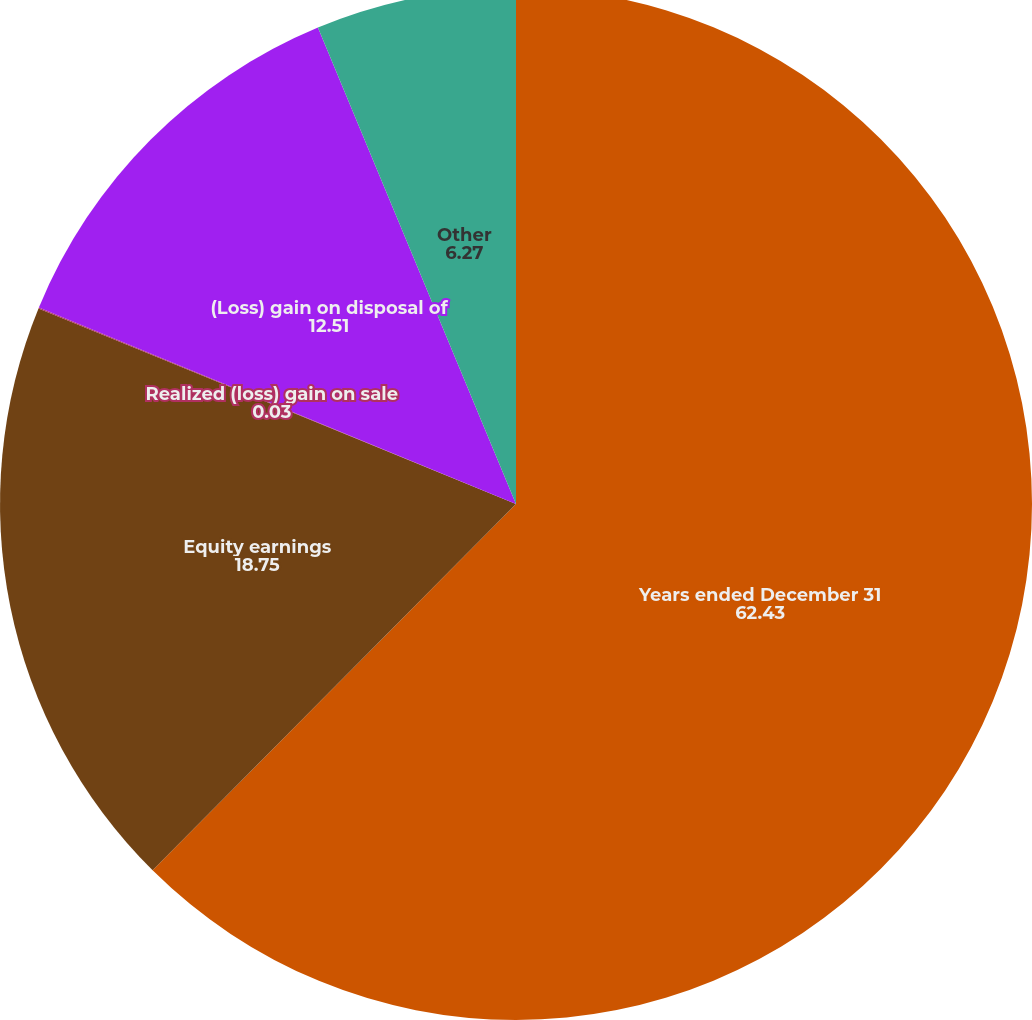Convert chart. <chart><loc_0><loc_0><loc_500><loc_500><pie_chart><fcel>Years ended December 31<fcel>Equity earnings<fcel>Realized (loss) gain on sale<fcel>(Loss) gain on disposal of<fcel>Other<nl><fcel>62.43%<fcel>18.75%<fcel>0.03%<fcel>12.51%<fcel>6.27%<nl></chart> 